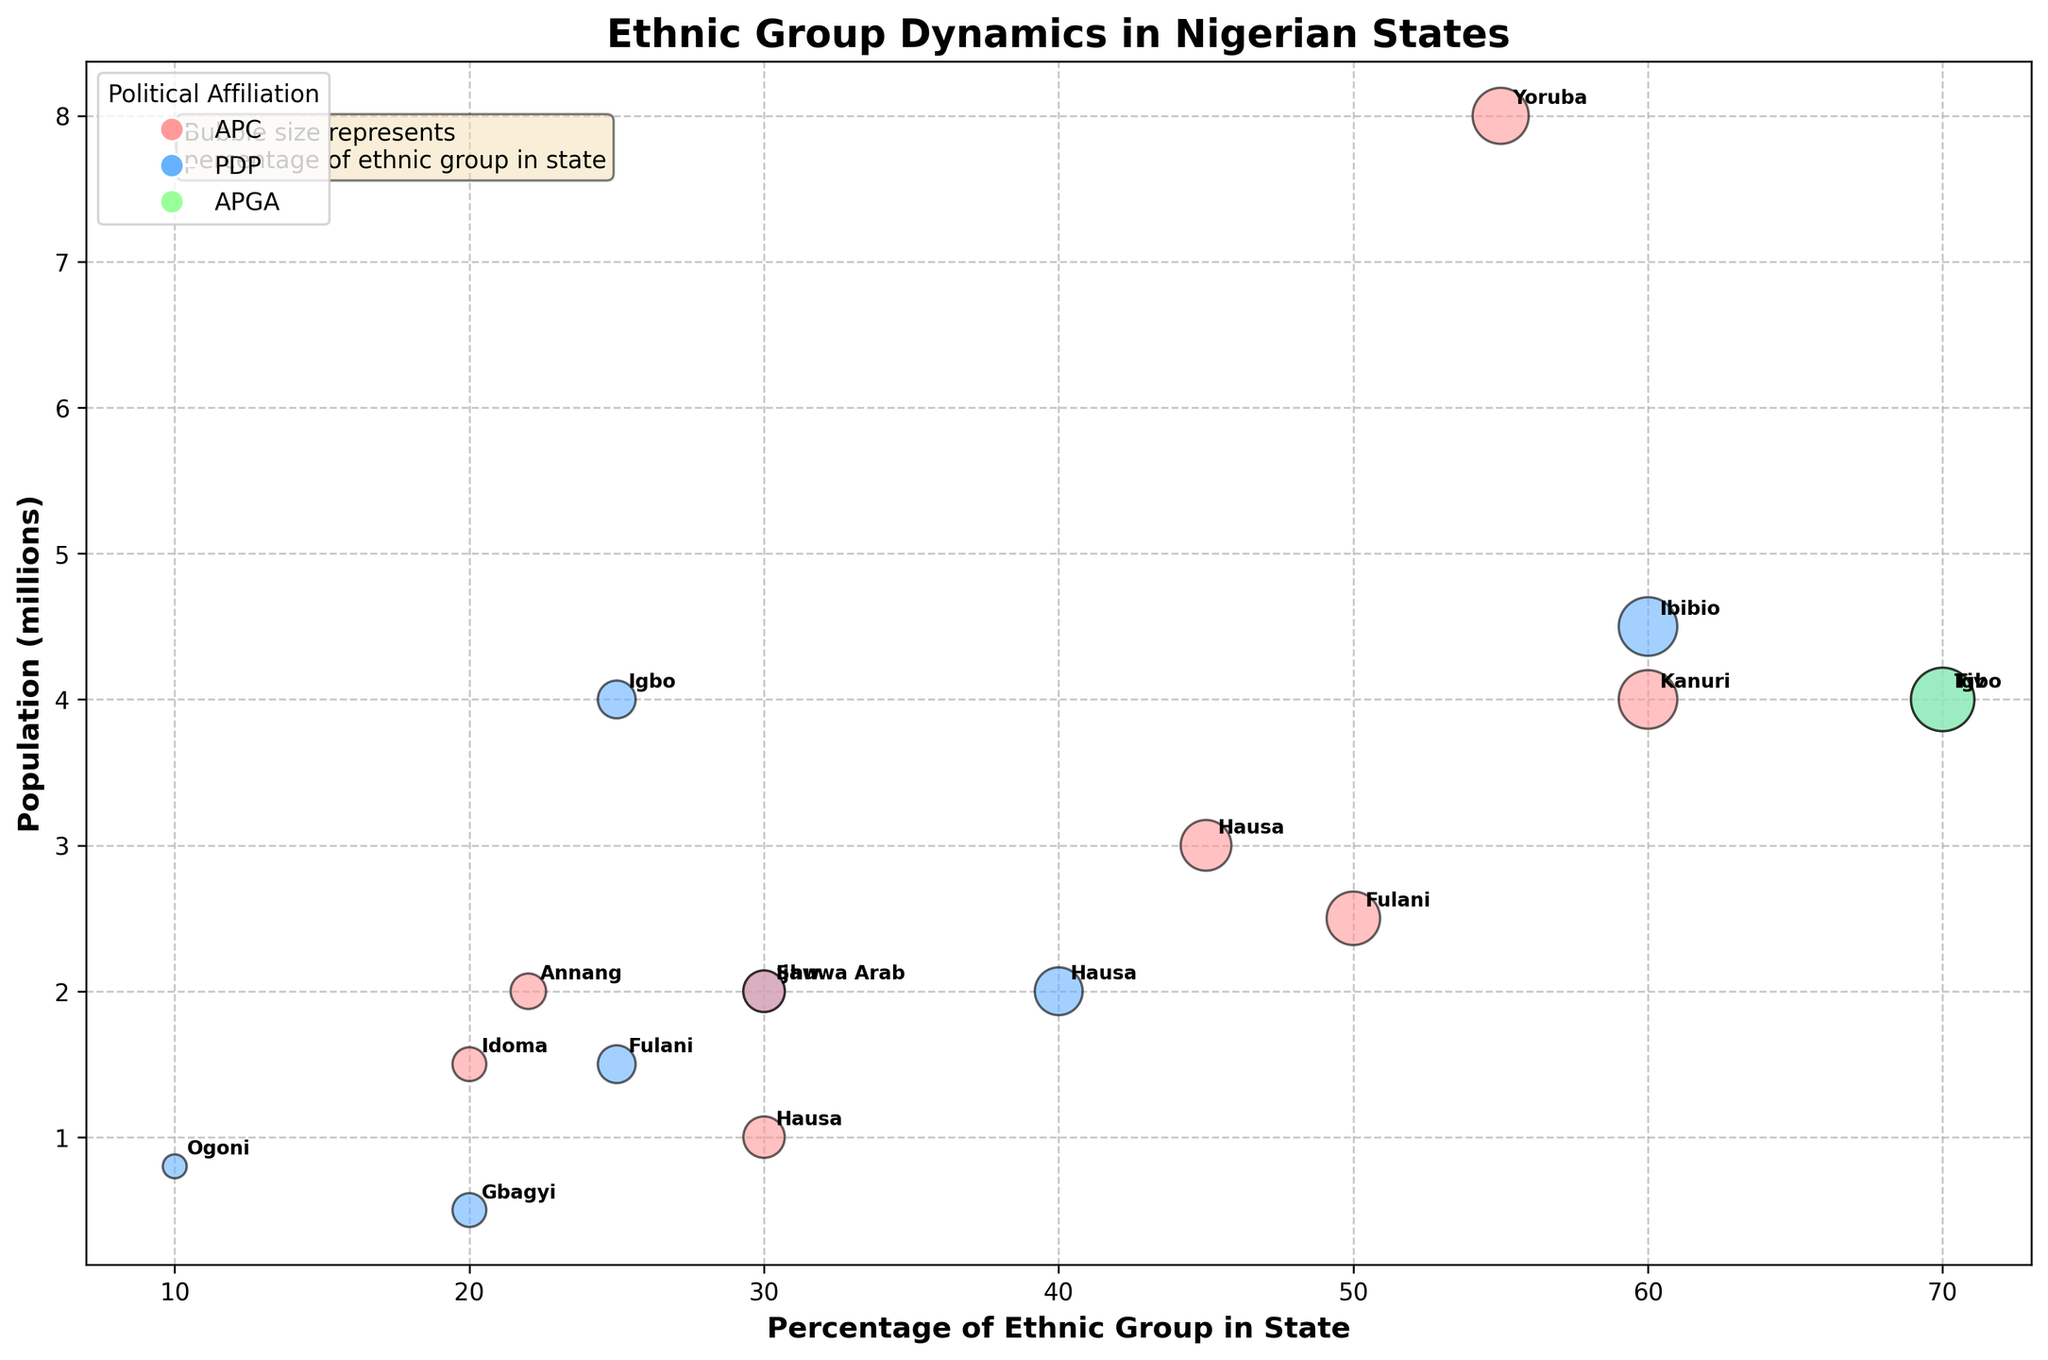What is the title of the figure? The title of the figure can be found at the top of the chart.
Answer: Ethnic Group Dynamics in Nigerian States Which ethnic group has the largest bubble in the State of Benue? The largest bubble in Benue represents the ethnic group with the highest percentage.
Answer: Tiv What is the y-axis representing in this bubble chart? The y-axis label, found on the left side of the chart, specifies what the axis represents.
Answer: Population (millions) Which ethnic group in Lagos has a higher percentage, Yoruba or Igbo? By comparing the positions of the Yoruba and Igbo bubbles along the x-axis for Lagos state, we see where the Yoruba bubble is placed at 55 and the Igbo bubble at 25.
Answer: Yoruba How many ethnic groups are affiliated with APC across all the states? Count the number of bubbles colored to represent APC in the legend (#FF9999).
Answer: 6 What can you infer from the bubble size and political affiliation of the Fulani in Sokoto? The bubble size represents the percentage (50%) and the color indicates APC affiliation.
Answer: 50%, APC Which state has the highest population for a single ethnic group and what is that group? Identify the bubble with the highest position (y-axis) and check the label for the ethnic group and state.
Answer: Yoruba, Lagos Compare the percentages of the Hausa ethnic group in Sokoto and Kaduna. Which one is higher and by how much? Look at the x-axis positions for the Hausa in both states; Sokoto is at 40%, and Kaduna is at 45%. Subtract the smaller percentage from the larger one (45 - 40).
Answer: Kaduna, 5% Which political affiliation is most common among the ethnic groups in Akwa Ibom? Check the colors of the bubbles in Akwa Ibom state to see which affiliation is represented most frequently.
Answer: PDP What is the combined population of Yoruba in Lagos and Tiv in Benue? Add the populations of Yoruba in Lagos (8 million) and Tiv in Benue (4 million).
Answer: 12 million 